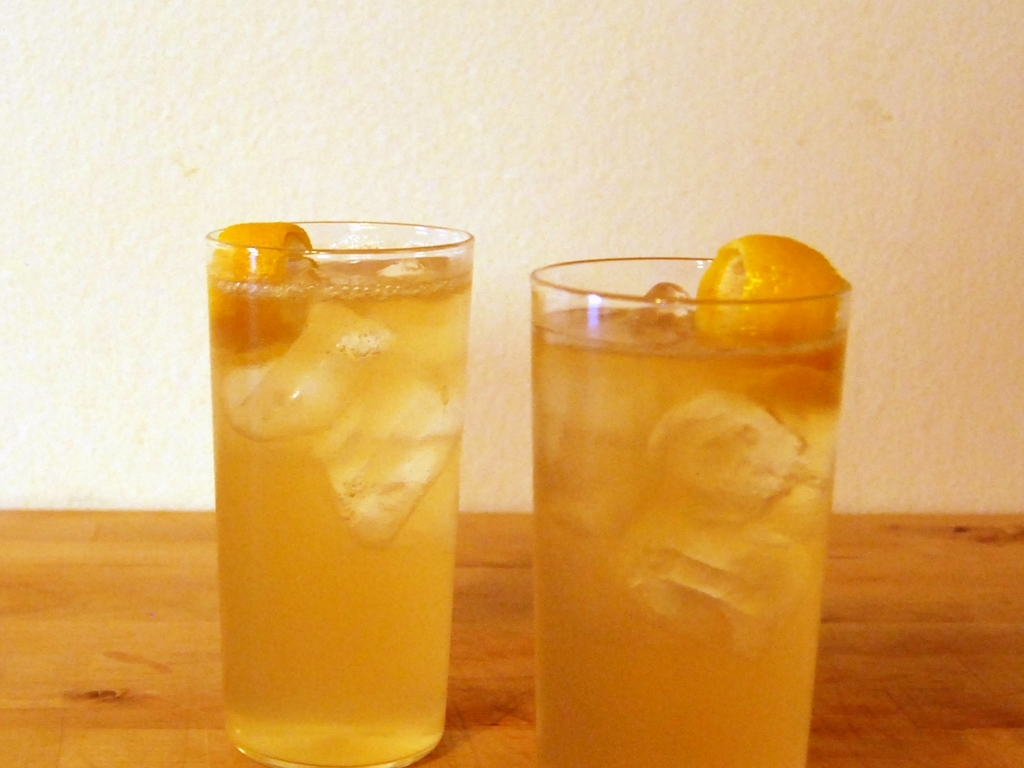What kind of drinks are these, and are they suitable for a summer day? These appear to be iced tea beverages, commonly enjoyed for their refreshing qualities. With ice and a garnish of citrus, likely lemon or orange, these drinks would be wonderfully suitable for a summer day, providing hydration and a citrusy zest to help cool down in the heat. 